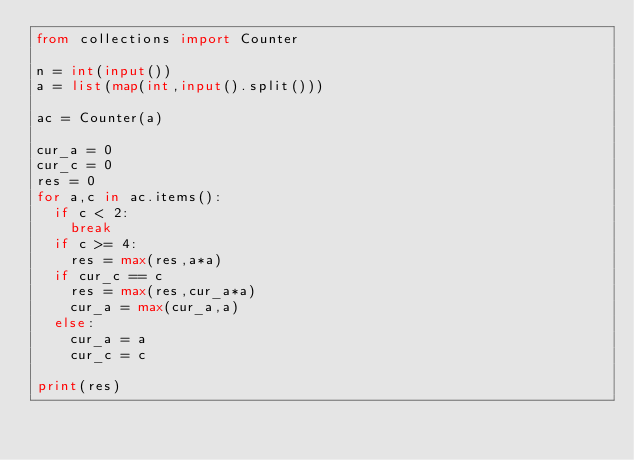<code> <loc_0><loc_0><loc_500><loc_500><_Python_>from collections import Counter

n = int(input())
a = list(map(int,input().split()))

ac = Counter(a)

cur_a = 0
cur_c = 0
res = 0
for a,c in ac.items():
	if c < 2:
		break
	if c >= 4:
		res = max(res,a*a)
	if cur_c == c
		res = max(res,cur_a*a)
		cur_a = max(cur_a,a)
	else:
		cur_a = a
		cur_c = c

print(res)</code> 